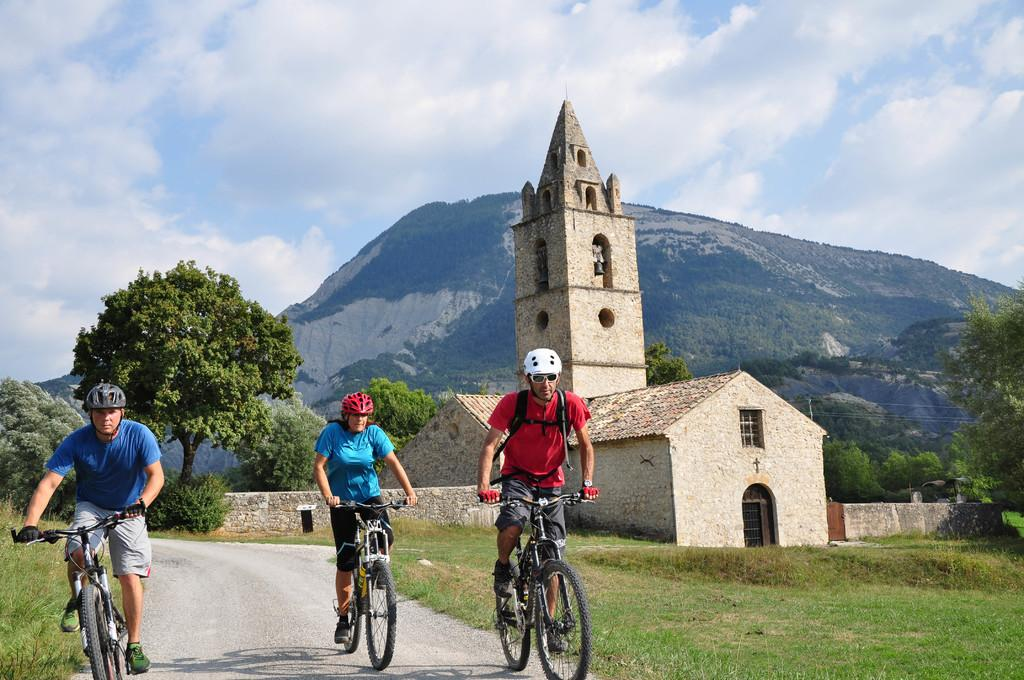What are the people in the image doing? The people in the image are riding bicycles on the road. What can be seen in the background of the image? There are hills in the background of the image. What type of structures are visible in the image? There are buildings visible in the image. What is present in the sky in the image? Clouds are present in the sky in the image. Can you tell me how many roses are being held by the people riding bicycles in the image? There are no roses present in the image; the people are riding bicycles. What type of part is being used by the people riding bicycles in the image? There is no specific part mentioned in the image; the people are simply riding bicycles. 